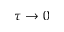<formula> <loc_0><loc_0><loc_500><loc_500>\tau \rightarrow 0</formula> 